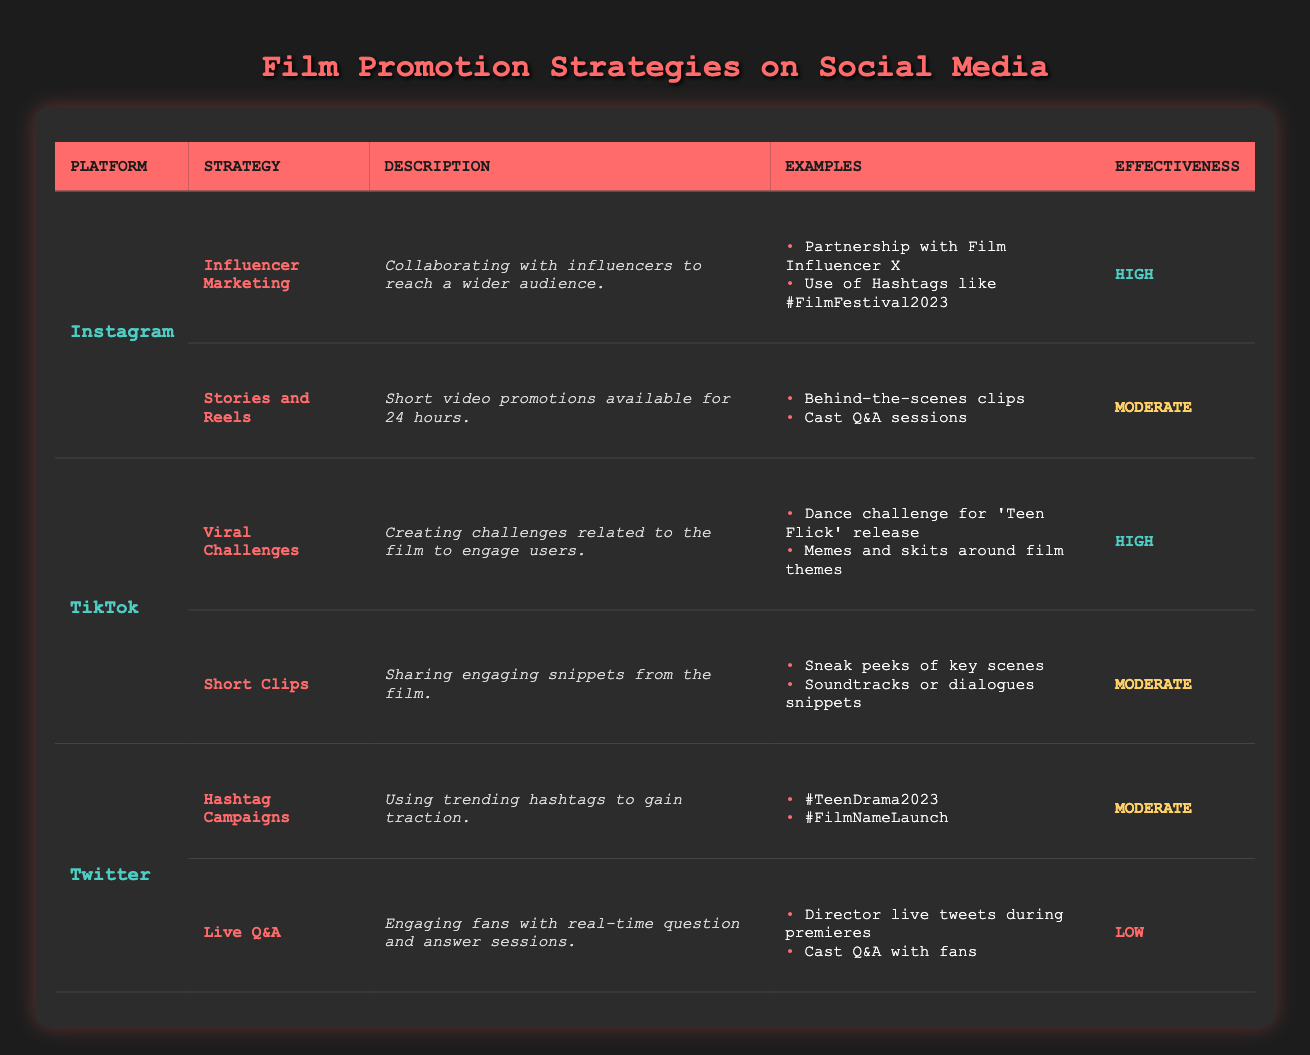What are the promotion strategies for Instagram? Referring to the table, the promotion strategies for Instagram are Influencer Marketing and Stories and Reels.
Answer: Influencer Marketing and Stories and Reels Which social media platform has the highest effectiveness for its promotion strategies? By examining the effectiveness column in the table, TikTok's promotion strategy Viral Challenges is noted as high, which is the highest effectiveness mentioned.
Answer: TikTok Are there any strategies in Twitter that have high effectiveness? Looking at the effectiveness of the strategies listed for Twitter, both Hashtag Campaigns and Live Q&A are noted as moderate and low respectively; therefore, there are no high effectiveness strategies.
Answer: No How many promotion strategies are classified as moderate? From the table, we see that Instagram has one moderate (Stories and Reels), TikTok has one moderate (Short Clips), and Twitter has two moderates (Hashtag Campaigns and Live Q&A). Adding these up gives us a total of four moderate strategies.
Answer: Four What is the difference in effectiveness between Instagram and TikTok's best strategies? TikTok's best strategy (Viral Challenges) has a high effectiveness, while Instagram's best strategy (Influencer Marketing) also has a high effectiveness. Since both are high, the difference is zero.
Answer: Zero Which platform's strategy has the lowest effectiveness and what is the strategy? According to the table, Twitter's Live Q&A strategy holds the lowest effectiveness, categorized as low.
Answer: Live Q&A What example did Instagram provide for its Influencer Marketing strategy? Looking under the examples for Influencer Marketing in the table, one example given is the "Partnership with Film Influencer X."
Answer: Partnership with Film Influencer X How many platforms have at least one strategy with high effectiveness? Examining the strategies, both Instagram (Influencer Marketing) and TikTok (Viral Challenges) have strategies labeled as high effectiveness; thus, there are two platforms that meet this criterion.
Answer: Two 